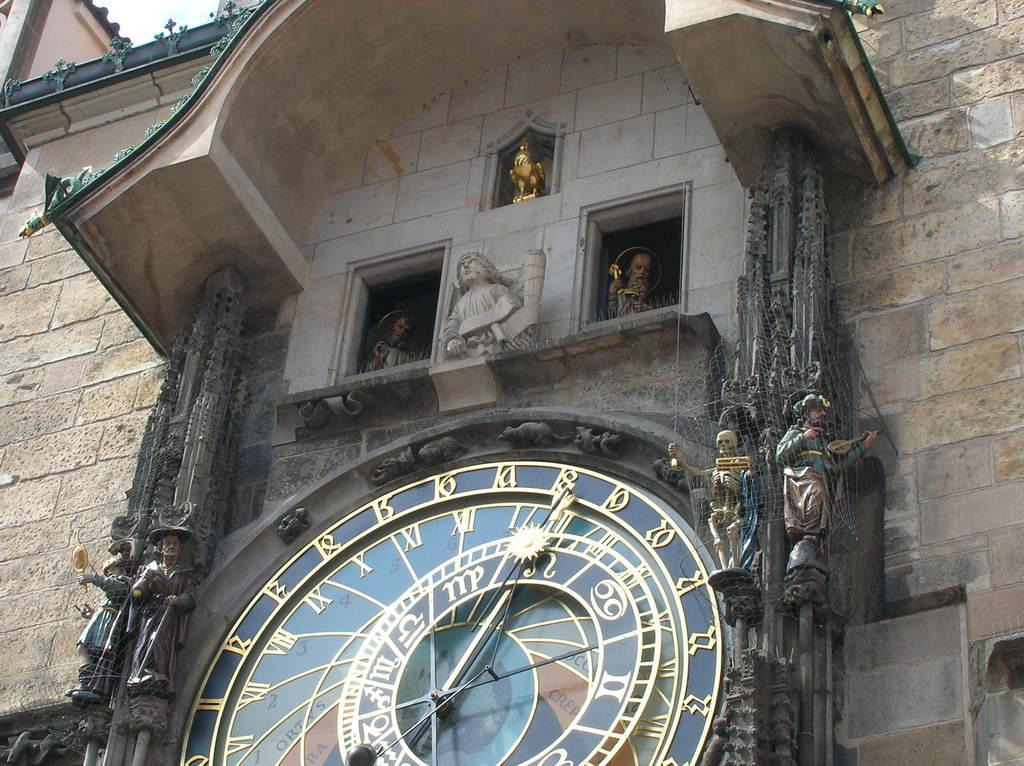What type of structure is depicted in the image? There is a historical building in the image. What decorative elements can be seen on the building? The building has sculptures on the wall. What time-keeping device is present in the image? There is a clock in the image. How is the clock designed? The clock is designed, but the specific design details are not mentioned in the facts. What type of attack is being carried out on the building in the image? There is no attack depicted in the image; it shows a historical building with sculptures on the wall and a clock. How does the sun affect the appearance of the building in the image? The facts provided do not mention the sun or its effect on the building's appearance, so we cannot answer this question based on the given information. 